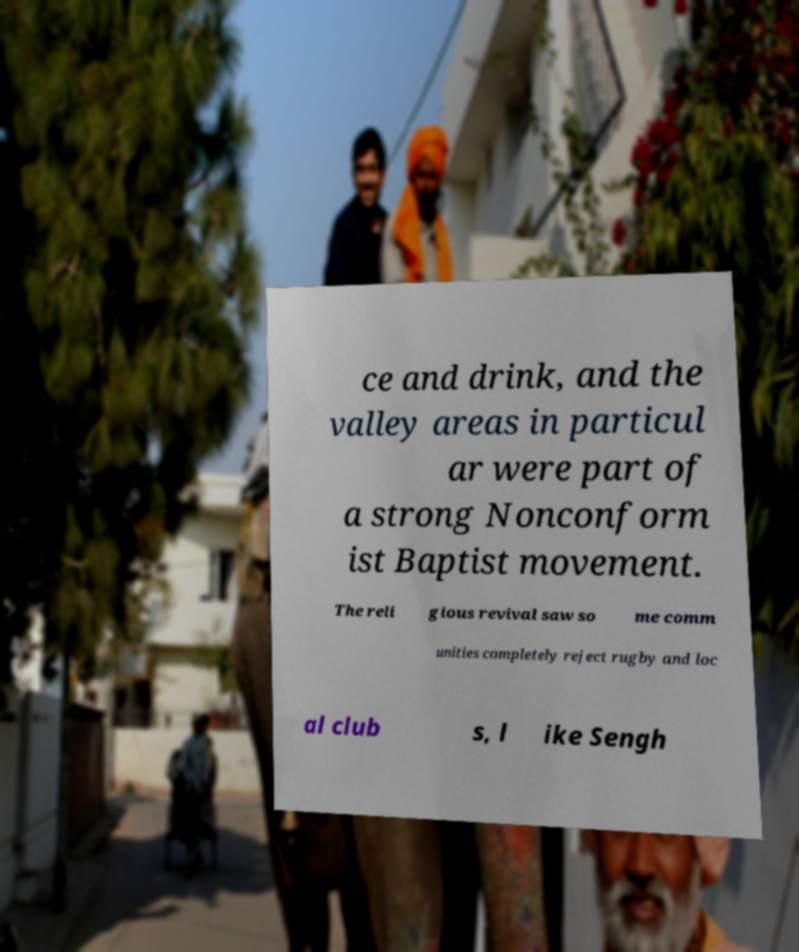Can you accurately transcribe the text from the provided image for me? ce and drink, and the valley areas in particul ar were part of a strong Nonconform ist Baptist movement. The reli gious revival saw so me comm unities completely reject rugby and loc al club s, l ike Sengh 